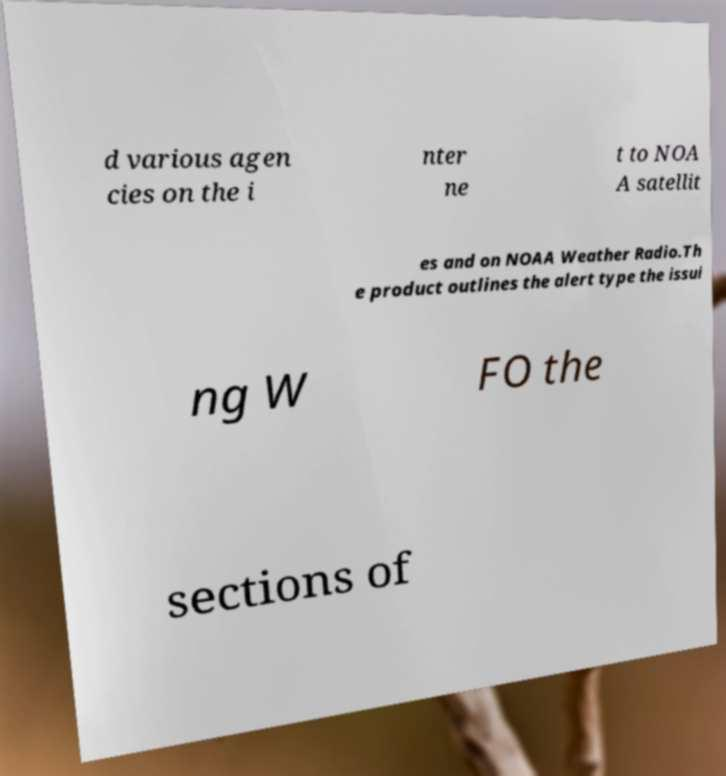Please identify and transcribe the text found in this image. d various agen cies on the i nter ne t to NOA A satellit es and on NOAA Weather Radio.Th e product outlines the alert type the issui ng W FO the sections of 